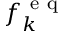<formula> <loc_0><loc_0><loc_500><loc_500>f _ { k } ^ { e q }</formula> 